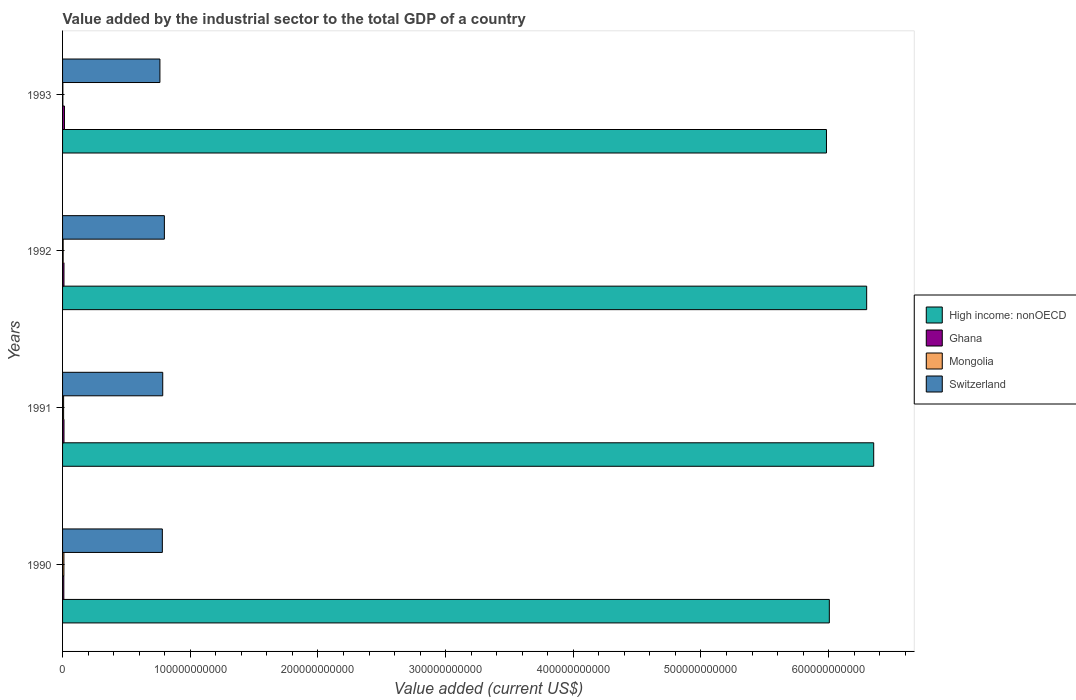How many different coloured bars are there?
Your answer should be compact. 4. Are the number of bars on each tick of the Y-axis equal?
Offer a very short reply. Yes. How many bars are there on the 3rd tick from the top?
Keep it short and to the point. 4. What is the label of the 1st group of bars from the top?
Your answer should be very brief. 1993. In how many cases, is the number of bars for a given year not equal to the number of legend labels?
Give a very brief answer. 0. What is the value added by the industrial sector to the total GDP in Switzerland in 1990?
Your answer should be very brief. 7.81e+1. Across all years, what is the maximum value added by the industrial sector to the total GDP in Ghana?
Provide a succinct answer. 1.48e+09. Across all years, what is the minimum value added by the industrial sector to the total GDP in Switzerland?
Give a very brief answer. 7.62e+1. In which year was the value added by the industrial sector to the total GDP in Mongolia maximum?
Offer a terse response. 1990. In which year was the value added by the industrial sector to the total GDP in Ghana minimum?
Offer a terse response. 1990. What is the total value added by the industrial sector to the total GDP in Mongolia in the graph?
Keep it short and to the point. 2.56e+09. What is the difference between the value added by the industrial sector to the total GDP in Ghana in 1991 and that in 1992?
Ensure brevity in your answer.  4.63e+06. What is the difference between the value added by the industrial sector to the total GDP in Mongolia in 1990 and the value added by the industrial sector to the total GDP in High income: nonOECD in 1992?
Keep it short and to the point. -6.29e+11. What is the average value added by the industrial sector to the total GDP in High income: nonOECD per year?
Ensure brevity in your answer.  6.16e+11. In the year 1992, what is the difference between the value added by the industrial sector to the total GDP in Switzerland and value added by the industrial sector to the total GDP in High income: nonOECD?
Ensure brevity in your answer.  -5.50e+11. What is the ratio of the value added by the industrial sector to the total GDP in Ghana in 1991 to that in 1992?
Make the answer very short. 1. Is the difference between the value added by the industrial sector to the total GDP in Switzerland in 1990 and 1993 greater than the difference between the value added by the industrial sector to the total GDP in High income: nonOECD in 1990 and 1993?
Ensure brevity in your answer.  No. What is the difference between the highest and the second highest value added by the industrial sector to the total GDP in Switzerland?
Your answer should be compact. 1.29e+09. What is the difference between the highest and the lowest value added by the industrial sector to the total GDP in High income: nonOECD?
Ensure brevity in your answer.  3.70e+1. In how many years, is the value added by the industrial sector to the total GDP in Mongolia greater than the average value added by the industrial sector to the total GDP in Mongolia taken over all years?
Offer a very short reply. 2. Is the sum of the value added by the industrial sector to the total GDP in Mongolia in 1991 and 1993 greater than the maximum value added by the industrial sector to the total GDP in High income: nonOECD across all years?
Offer a very short reply. No. What does the 4th bar from the top in 1991 represents?
Your response must be concise. High income: nonOECD. What does the 3rd bar from the bottom in 1993 represents?
Give a very brief answer. Mongolia. Are all the bars in the graph horizontal?
Provide a short and direct response. Yes. How many years are there in the graph?
Keep it short and to the point. 4. What is the difference between two consecutive major ticks on the X-axis?
Offer a terse response. 1.00e+11. Does the graph contain any zero values?
Offer a very short reply. No. How many legend labels are there?
Your response must be concise. 4. What is the title of the graph?
Keep it short and to the point. Value added by the industrial sector to the total GDP of a country. What is the label or title of the X-axis?
Give a very brief answer. Value added (current US$). What is the label or title of the Y-axis?
Your answer should be compact. Years. What is the Value added (current US$) in High income: nonOECD in 1990?
Offer a terse response. 6.01e+11. What is the Value added (current US$) in Ghana in 1990?
Provide a succinct answer. 9.88e+08. What is the Value added (current US$) of Mongolia in 1990?
Your answer should be very brief. 1.06e+09. What is the Value added (current US$) of Switzerland in 1990?
Your answer should be very brief. 7.81e+1. What is the Value added (current US$) in High income: nonOECD in 1991?
Your answer should be very brief. 6.35e+11. What is the Value added (current US$) in Ghana in 1991?
Make the answer very short. 1.12e+09. What is the Value added (current US$) in Mongolia in 1991?
Provide a short and direct response. 8.17e+08. What is the Value added (current US$) in Switzerland in 1991?
Provide a short and direct response. 7.85e+1. What is the Value added (current US$) in High income: nonOECD in 1992?
Provide a succinct answer. 6.30e+11. What is the Value added (current US$) in Ghana in 1992?
Make the answer very short. 1.11e+09. What is the Value added (current US$) of Mongolia in 1992?
Provide a succinct answer. 4.57e+08. What is the Value added (current US$) in Switzerland in 1992?
Make the answer very short. 7.97e+1. What is the Value added (current US$) of High income: nonOECD in 1993?
Provide a short and direct response. 5.98e+11. What is the Value added (current US$) of Ghana in 1993?
Keep it short and to the point. 1.48e+09. What is the Value added (current US$) in Mongolia in 1993?
Provide a short and direct response. 2.31e+08. What is the Value added (current US$) of Switzerland in 1993?
Your answer should be very brief. 7.62e+1. Across all years, what is the maximum Value added (current US$) in High income: nonOECD?
Provide a short and direct response. 6.35e+11. Across all years, what is the maximum Value added (current US$) of Ghana?
Keep it short and to the point. 1.48e+09. Across all years, what is the maximum Value added (current US$) in Mongolia?
Offer a very short reply. 1.06e+09. Across all years, what is the maximum Value added (current US$) of Switzerland?
Your response must be concise. 7.97e+1. Across all years, what is the minimum Value added (current US$) of High income: nonOECD?
Offer a terse response. 5.98e+11. Across all years, what is the minimum Value added (current US$) of Ghana?
Your answer should be compact. 9.88e+08. Across all years, what is the minimum Value added (current US$) of Mongolia?
Your answer should be compact. 2.31e+08. Across all years, what is the minimum Value added (current US$) of Switzerland?
Keep it short and to the point. 7.62e+1. What is the total Value added (current US$) of High income: nonOECD in the graph?
Keep it short and to the point. 2.46e+12. What is the total Value added (current US$) of Ghana in the graph?
Provide a short and direct response. 4.70e+09. What is the total Value added (current US$) in Mongolia in the graph?
Your answer should be compact. 2.56e+09. What is the total Value added (current US$) in Switzerland in the graph?
Ensure brevity in your answer.  3.13e+11. What is the difference between the Value added (current US$) in High income: nonOECD in 1990 and that in 1991?
Give a very brief answer. -3.48e+1. What is the difference between the Value added (current US$) in Ghana in 1990 and that in 1991?
Offer a terse response. -1.31e+08. What is the difference between the Value added (current US$) of Mongolia in 1990 and that in 1991?
Provide a short and direct response. 2.39e+08. What is the difference between the Value added (current US$) in Switzerland in 1990 and that in 1991?
Your response must be concise. -3.05e+08. What is the difference between the Value added (current US$) of High income: nonOECD in 1990 and that in 1992?
Ensure brevity in your answer.  -2.92e+1. What is the difference between the Value added (current US$) of Ghana in 1990 and that in 1992?
Offer a very short reply. -1.27e+08. What is the difference between the Value added (current US$) of Mongolia in 1990 and that in 1992?
Your answer should be very brief. 5.98e+08. What is the difference between the Value added (current US$) of Switzerland in 1990 and that in 1992?
Provide a short and direct response. -1.59e+09. What is the difference between the Value added (current US$) of High income: nonOECD in 1990 and that in 1993?
Give a very brief answer. 2.24e+09. What is the difference between the Value added (current US$) of Ghana in 1990 and that in 1993?
Ensure brevity in your answer.  -4.93e+08. What is the difference between the Value added (current US$) of Mongolia in 1990 and that in 1993?
Your response must be concise. 8.25e+08. What is the difference between the Value added (current US$) of Switzerland in 1990 and that in 1993?
Your response must be concise. 1.90e+09. What is the difference between the Value added (current US$) in High income: nonOECD in 1991 and that in 1992?
Ensure brevity in your answer.  5.51e+09. What is the difference between the Value added (current US$) in Ghana in 1991 and that in 1992?
Your answer should be compact. 4.63e+06. What is the difference between the Value added (current US$) in Mongolia in 1991 and that in 1992?
Provide a succinct answer. 3.60e+08. What is the difference between the Value added (current US$) of Switzerland in 1991 and that in 1992?
Offer a terse response. -1.29e+09. What is the difference between the Value added (current US$) in High income: nonOECD in 1991 and that in 1993?
Offer a terse response. 3.70e+1. What is the difference between the Value added (current US$) in Ghana in 1991 and that in 1993?
Your answer should be very brief. -3.62e+08. What is the difference between the Value added (current US$) in Mongolia in 1991 and that in 1993?
Give a very brief answer. 5.86e+08. What is the difference between the Value added (current US$) of Switzerland in 1991 and that in 1993?
Your answer should be compact. 2.20e+09. What is the difference between the Value added (current US$) of High income: nonOECD in 1992 and that in 1993?
Provide a succinct answer. 3.15e+1. What is the difference between the Value added (current US$) of Ghana in 1992 and that in 1993?
Give a very brief answer. -3.66e+08. What is the difference between the Value added (current US$) in Mongolia in 1992 and that in 1993?
Keep it short and to the point. 2.26e+08. What is the difference between the Value added (current US$) in Switzerland in 1992 and that in 1993?
Provide a succinct answer. 3.49e+09. What is the difference between the Value added (current US$) in High income: nonOECD in 1990 and the Value added (current US$) in Ghana in 1991?
Ensure brevity in your answer.  5.99e+11. What is the difference between the Value added (current US$) in High income: nonOECD in 1990 and the Value added (current US$) in Mongolia in 1991?
Keep it short and to the point. 6.00e+11. What is the difference between the Value added (current US$) of High income: nonOECD in 1990 and the Value added (current US$) of Switzerland in 1991?
Offer a very short reply. 5.22e+11. What is the difference between the Value added (current US$) in Ghana in 1990 and the Value added (current US$) in Mongolia in 1991?
Keep it short and to the point. 1.71e+08. What is the difference between the Value added (current US$) of Ghana in 1990 and the Value added (current US$) of Switzerland in 1991?
Ensure brevity in your answer.  -7.75e+1. What is the difference between the Value added (current US$) in Mongolia in 1990 and the Value added (current US$) in Switzerland in 1991?
Give a very brief answer. -7.74e+1. What is the difference between the Value added (current US$) in High income: nonOECD in 1990 and the Value added (current US$) in Ghana in 1992?
Provide a short and direct response. 5.99e+11. What is the difference between the Value added (current US$) of High income: nonOECD in 1990 and the Value added (current US$) of Mongolia in 1992?
Provide a short and direct response. 6.00e+11. What is the difference between the Value added (current US$) in High income: nonOECD in 1990 and the Value added (current US$) in Switzerland in 1992?
Keep it short and to the point. 5.21e+11. What is the difference between the Value added (current US$) in Ghana in 1990 and the Value added (current US$) in Mongolia in 1992?
Give a very brief answer. 5.31e+08. What is the difference between the Value added (current US$) of Ghana in 1990 and the Value added (current US$) of Switzerland in 1992?
Your answer should be very brief. -7.88e+1. What is the difference between the Value added (current US$) in Mongolia in 1990 and the Value added (current US$) in Switzerland in 1992?
Ensure brevity in your answer.  -7.87e+1. What is the difference between the Value added (current US$) in High income: nonOECD in 1990 and the Value added (current US$) in Ghana in 1993?
Offer a terse response. 5.99e+11. What is the difference between the Value added (current US$) of High income: nonOECD in 1990 and the Value added (current US$) of Mongolia in 1993?
Your answer should be compact. 6.00e+11. What is the difference between the Value added (current US$) in High income: nonOECD in 1990 and the Value added (current US$) in Switzerland in 1993?
Offer a terse response. 5.24e+11. What is the difference between the Value added (current US$) of Ghana in 1990 and the Value added (current US$) of Mongolia in 1993?
Ensure brevity in your answer.  7.57e+08. What is the difference between the Value added (current US$) of Ghana in 1990 and the Value added (current US$) of Switzerland in 1993?
Your response must be concise. -7.53e+1. What is the difference between the Value added (current US$) of Mongolia in 1990 and the Value added (current US$) of Switzerland in 1993?
Make the answer very short. -7.52e+1. What is the difference between the Value added (current US$) of High income: nonOECD in 1991 and the Value added (current US$) of Ghana in 1992?
Ensure brevity in your answer.  6.34e+11. What is the difference between the Value added (current US$) in High income: nonOECD in 1991 and the Value added (current US$) in Mongolia in 1992?
Make the answer very short. 6.35e+11. What is the difference between the Value added (current US$) of High income: nonOECD in 1991 and the Value added (current US$) of Switzerland in 1992?
Provide a short and direct response. 5.56e+11. What is the difference between the Value added (current US$) of Ghana in 1991 and the Value added (current US$) of Mongolia in 1992?
Ensure brevity in your answer.  6.62e+08. What is the difference between the Value added (current US$) in Ghana in 1991 and the Value added (current US$) in Switzerland in 1992?
Your response must be concise. -7.86e+1. What is the difference between the Value added (current US$) of Mongolia in 1991 and the Value added (current US$) of Switzerland in 1992?
Provide a short and direct response. -7.89e+1. What is the difference between the Value added (current US$) in High income: nonOECD in 1991 and the Value added (current US$) in Ghana in 1993?
Give a very brief answer. 6.34e+11. What is the difference between the Value added (current US$) in High income: nonOECD in 1991 and the Value added (current US$) in Mongolia in 1993?
Your answer should be very brief. 6.35e+11. What is the difference between the Value added (current US$) of High income: nonOECD in 1991 and the Value added (current US$) of Switzerland in 1993?
Ensure brevity in your answer.  5.59e+11. What is the difference between the Value added (current US$) of Ghana in 1991 and the Value added (current US$) of Mongolia in 1993?
Offer a terse response. 8.88e+08. What is the difference between the Value added (current US$) of Ghana in 1991 and the Value added (current US$) of Switzerland in 1993?
Offer a terse response. -7.51e+1. What is the difference between the Value added (current US$) of Mongolia in 1991 and the Value added (current US$) of Switzerland in 1993?
Your answer should be compact. -7.54e+1. What is the difference between the Value added (current US$) in High income: nonOECD in 1992 and the Value added (current US$) in Ghana in 1993?
Offer a terse response. 6.28e+11. What is the difference between the Value added (current US$) in High income: nonOECD in 1992 and the Value added (current US$) in Mongolia in 1993?
Your answer should be compact. 6.30e+11. What is the difference between the Value added (current US$) of High income: nonOECD in 1992 and the Value added (current US$) of Switzerland in 1993?
Your response must be concise. 5.54e+11. What is the difference between the Value added (current US$) of Ghana in 1992 and the Value added (current US$) of Mongolia in 1993?
Offer a very short reply. 8.84e+08. What is the difference between the Value added (current US$) in Ghana in 1992 and the Value added (current US$) in Switzerland in 1993?
Offer a terse response. -7.51e+1. What is the difference between the Value added (current US$) in Mongolia in 1992 and the Value added (current US$) in Switzerland in 1993?
Offer a very short reply. -7.58e+1. What is the average Value added (current US$) in High income: nonOECD per year?
Ensure brevity in your answer.  6.16e+11. What is the average Value added (current US$) of Ghana per year?
Provide a succinct answer. 1.18e+09. What is the average Value added (current US$) in Mongolia per year?
Ensure brevity in your answer.  6.40e+08. What is the average Value added (current US$) in Switzerland per year?
Keep it short and to the point. 7.81e+1. In the year 1990, what is the difference between the Value added (current US$) of High income: nonOECD and Value added (current US$) of Ghana?
Make the answer very short. 6.00e+11. In the year 1990, what is the difference between the Value added (current US$) in High income: nonOECD and Value added (current US$) in Mongolia?
Keep it short and to the point. 5.99e+11. In the year 1990, what is the difference between the Value added (current US$) in High income: nonOECD and Value added (current US$) in Switzerland?
Provide a short and direct response. 5.22e+11. In the year 1990, what is the difference between the Value added (current US$) in Ghana and Value added (current US$) in Mongolia?
Your answer should be very brief. -6.76e+07. In the year 1990, what is the difference between the Value added (current US$) in Ghana and Value added (current US$) in Switzerland?
Your answer should be compact. -7.72e+1. In the year 1990, what is the difference between the Value added (current US$) in Mongolia and Value added (current US$) in Switzerland?
Ensure brevity in your answer.  -7.71e+1. In the year 1991, what is the difference between the Value added (current US$) of High income: nonOECD and Value added (current US$) of Ghana?
Your response must be concise. 6.34e+11. In the year 1991, what is the difference between the Value added (current US$) of High income: nonOECD and Value added (current US$) of Mongolia?
Offer a terse response. 6.34e+11. In the year 1991, what is the difference between the Value added (current US$) in High income: nonOECD and Value added (current US$) in Switzerland?
Your response must be concise. 5.57e+11. In the year 1991, what is the difference between the Value added (current US$) of Ghana and Value added (current US$) of Mongolia?
Provide a short and direct response. 3.02e+08. In the year 1991, what is the difference between the Value added (current US$) in Ghana and Value added (current US$) in Switzerland?
Keep it short and to the point. -7.73e+1. In the year 1991, what is the difference between the Value added (current US$) in Mongolia and Value added (current US$) in Switzerland?
Your response must be concise. -7.76e+1. In the year 1992, what is the difference between the Value added (current US$) in High income: nonOECD and Value added (current US$) in Ghana?
Keep it short and to the point. 6.29e+11. In the year 1992, what is the difference between the Value added (current US$) of High income: nonOECD and Value added (current US$) of Mongolia?
Give a very brief answer. 6.29e+11. In the year 1992, what is the difference between the Value added (current US$) in High income: nonOECD and Value added (current US$) in Switzerland?
Your answer should be very brief. 5.50e+11. In the year 1992, what is the difference between the Value added (current US$) of Ghana and Value added (current US$) of Mongolia?
Keep it short and to the point. 6.57e+08. In the year 1992, what is the difference between the Value added (current US$) of Ghana and Value added (current US$) of Switzerland?
Your answer should be compact. -7.86e+1. In the year 1992, what is the difference between the Value added (current US$) of Mongolia and Value added (current US$) of Switzerland?
Your answer should be compact. -7.93e+1. In the year 1993, what is the difference between the Value added (current US$) of High income: nonOECD and Value added (current US$) of Ghana?
Provide a succinct answer. 5.97e+11. In the year 1993, what is the difference between the Value added (current US$) of High income: nonOECD and Value added (current US$) of Mongolia?
Your answer should be compact. 5.98e+11. In the year 1993, what is the difference between the Value added (current US$) of High income: nonOECD and Value added (current US$) of Switzerland?
Offer a very short reply. 5.22e+11. In the year 1993, what is the difference between the Value added (current US$) of Ghana and Value added (current US$) of Mongolia?
Keep it short and to the point. 1.25e+09. In the year 1993, what is the difference between the Value added (current US$) of Ghana and Value added (current US$) of Switzerland?
Your answer should be compact. -7.48e+1. In the year 1993, what is the difference between the Value added (current US$) in Mongolia and Value added (current US$) in Switzerland?
Your response must be concise. -7.60e+1. What is the ratio of the Value added (current US$) of High income: nonOECD in 1990 to that in 1991?
Your answer should be compact. 0.95. What is the ratio of the Value added (current US$) of Ghana in 1990 to that in 1991?
Your answer should be very brief. 0.88. What is the ratio of the Value added (current US$) in Mongolia in 1990 to that in 1991?
Your answer should be compact. 1.29. What is the ratio of the Value added (current US$) in High income: nonOECD in 1990 to that in 1992?
Your answer should be very brief. 0.95. What is the ratio of the Value added (current US$) in Ghana in 1990 to that in 1992?
Keep it short and to the point. 0.89. What is the ratio of the Value added (current US$) of Mongolia in 1990 to that in 1992?
Offer a very short reply. 2.31. What is the ratio of the Value added (current US$) of Switzerland in 1990 to that in 1992?
Offer a terse response. 0.98. What is the ratio of the Value added (current US$) in Ghana in 1990 to that in 1993?
Your answer should be compact. 0.67. What is the ratio of the Value added (current US$) of Mongolia in 1990 to that in 1993?
Offer a very short reply. 4.57. What is the ratio of the Value added (current US$) in Switzerland in 1990 to that in 1993?
Your answer should be very brief. 1.02. What is the ratio of the Value added (current US$) in High income: nonOECD in 1991 to that in 1992?
Your response must be concise. 1.01. What is the ratio of the Value added (current US$) in Ghana in 1991 to that in 1992?
Ensure brevity in your answer.  1. What is the ratio of the Value added (current US$) in Mongolia in 1991 to that in 1992?
Your answer should be compact. 1.79. What is the ratio of the Value added (current US$) of Switzerland in 1991 to that in 1992?
Provide a short and direct response. 0.98. What is the ratio of the Value added (current US$) of High income: nonOECD in 1991 to that in 1993?
Offer a terse response. 1.06. What is the ratio of the Value added (current US$) of Ghana in 1991 to that in 1993?
Your response must be concise. 0.76. What is the ratio of the Value added (current US$) in Mongolia in 1991 to that in 1993?
Ensure brevity in your answer.  3.54. What is the ratio of the Value added (current US$) of Switzerland in 1991 to that in 1993?
Offer a terse response. 1.03. What is the ratio of the Value added (current US$) in High income: nonOECD in 1992 to that in 1993?
Your answer should be very brief. 1.05. What is the ratio of the Value added (current US$) in Ghana in 1992 to that in 1993?
Offer a very short reply. 0.75. What is the ratio of the Value added (current US$) of Mongolia in 1992 to that in 1993?
Your answer should be very brief. 1.98. What is the ratio of the Value added (current US$) in Switzerland in 1992 to that in 1993?
Keep it short and to the point. 1.05. What is the difference between the highest and the second highest Value added (current US$) in High income: nonOECD?
Ensure brevity in your answer.  5.51e+09. What is the difference between the highest and the second highest Value added (current US$) in Ghana?
Your answer should be compact. 3.62e+08. What is the difference between the highest and the second highest Value added (current US$) of Mongolia?
Keep it short and to the point. 2.39e+08. What is the difference between the highest and the second highest Value added (current US$) of Switzerland?
Make the answer very short. 1.29e+09. What is the difference between the highest and the lowest Value added (current US$) in High income: nonOECD?
Your response must be concise. 3.70e+1. What is the difference between the highest and the lowest Value added (current US$) of Ghana?
Give a very brief answer. 4.93e+08. What is the difference between the highest and the lowest Value added (current US$) of Mongolia?
Your response must be concise. 8.25e+08. What is the difference between the highest and the lowest Value added (current US$) in Switzerland?
Offer a very short reply. 3.49e+09. 